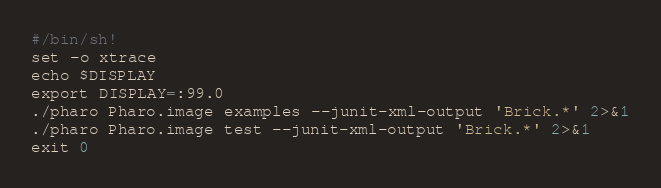Convert code to text. <code><loc_0><loc_0><loc_500><loc_500><_Bash_>#/bin/sh!
set -o xtrace
echo $DISPLAY
export DISPLAY=:99.0
./pharo Pharo.image examples --junit-xml-output 'Brick.*' 2>&1
./pharo Pharo.image test --junit-xml-output 'Brick.*' 2>&1
exit 0
</code> 